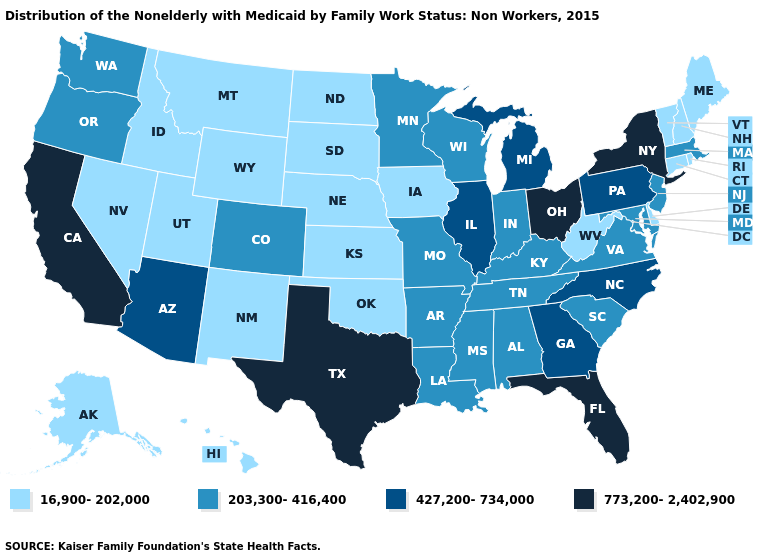Does Texas have the same value as Alaska?
Short answer required. No. Among the states that border Kentucky , which have the lowest value?
Keep it brief. West Virginia. Does Wisconsin have a higher value than New Hampshire?
Keep it brief. Yes. Which states have the highest value in the USA?
Be succinct. California, Florida, New York, Ohio, Texas. What is the lowest value in the USA?
Keep it brief. 16,900-202,000. What is the value of North Dakota?
Keep it brief. 16,900-202,000. Name the states that have a value in the range 773,200-2,402,900?
Be succinct. California, Florida, New York, Ohio, Texas. What is the highest value in the USA?
Give a very brief answer. 773,200-2,402,900. What is the highest value in the West ?
Keep it brief. 773,200-2,402,900. What is the value of Wyoming?
Be succinct. 16,900-202,000. What is the highest value in states that border New York?
Short answer required. 427,200-734,000. What is the highest value in the USA?
Short answer required. 773,200-2,402,900. What is the value of Louisiana?
Concise answer only. 203,300-416,400. Among the states that border South Carolina , which have the highest value?
Keep it brief. Georgia, North Carolina. Which states have the lowest value in the USA?
Short answer required. Alaska, Connecticut, Delaware, Hawaii, Idaho, Iowa, Kansas, Maine, Montana, Nebraska, Nevada, New Hampshire, New Mexico, North Dakota, Oklahoma, Rhode Island, South Dakota, Utah, Vermont, West Virginia, Wyoming. 